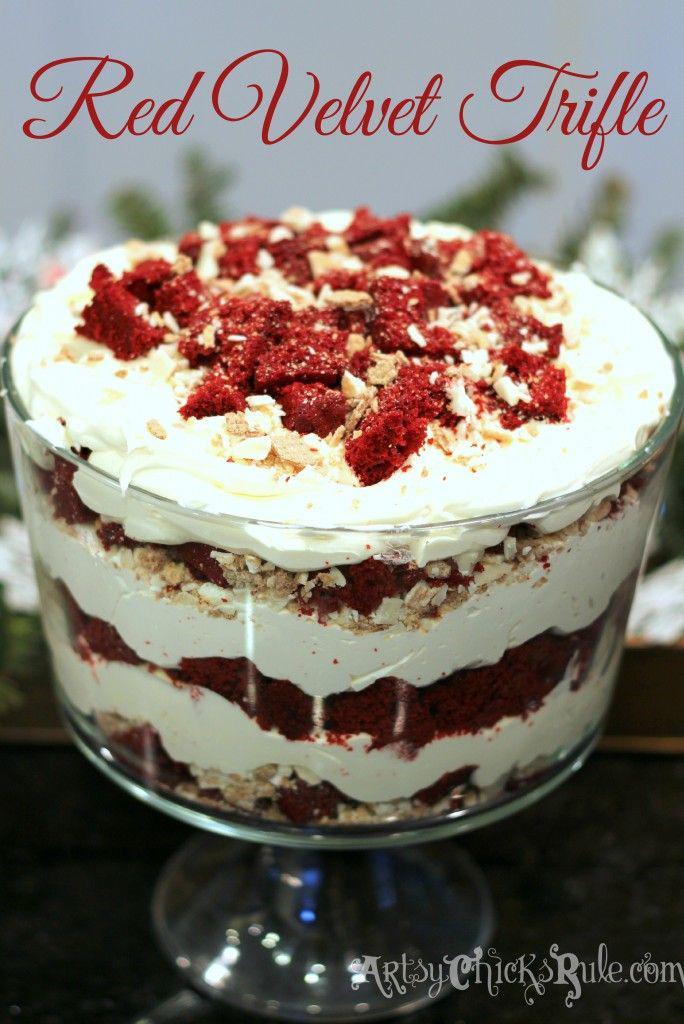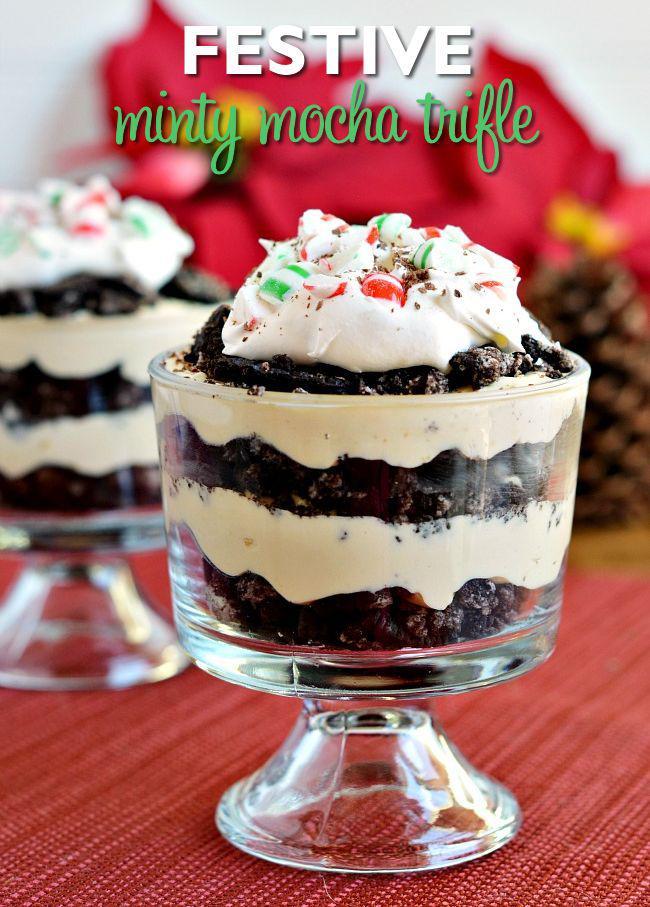The first image is the image on the left, the second image is the image on the right. For the images displayed, is the sentence "The image on the left shows a single bowl of trifle while the image on the right shows two pedestal bowls of trifle." factually correct? Answer yes or no. Yes. The first image is the image on the left, the second image is the image on the right. For the images shown, is this caption "cream layered desserts with at least 1 cherry on top" true? Answer yes or no. No. 